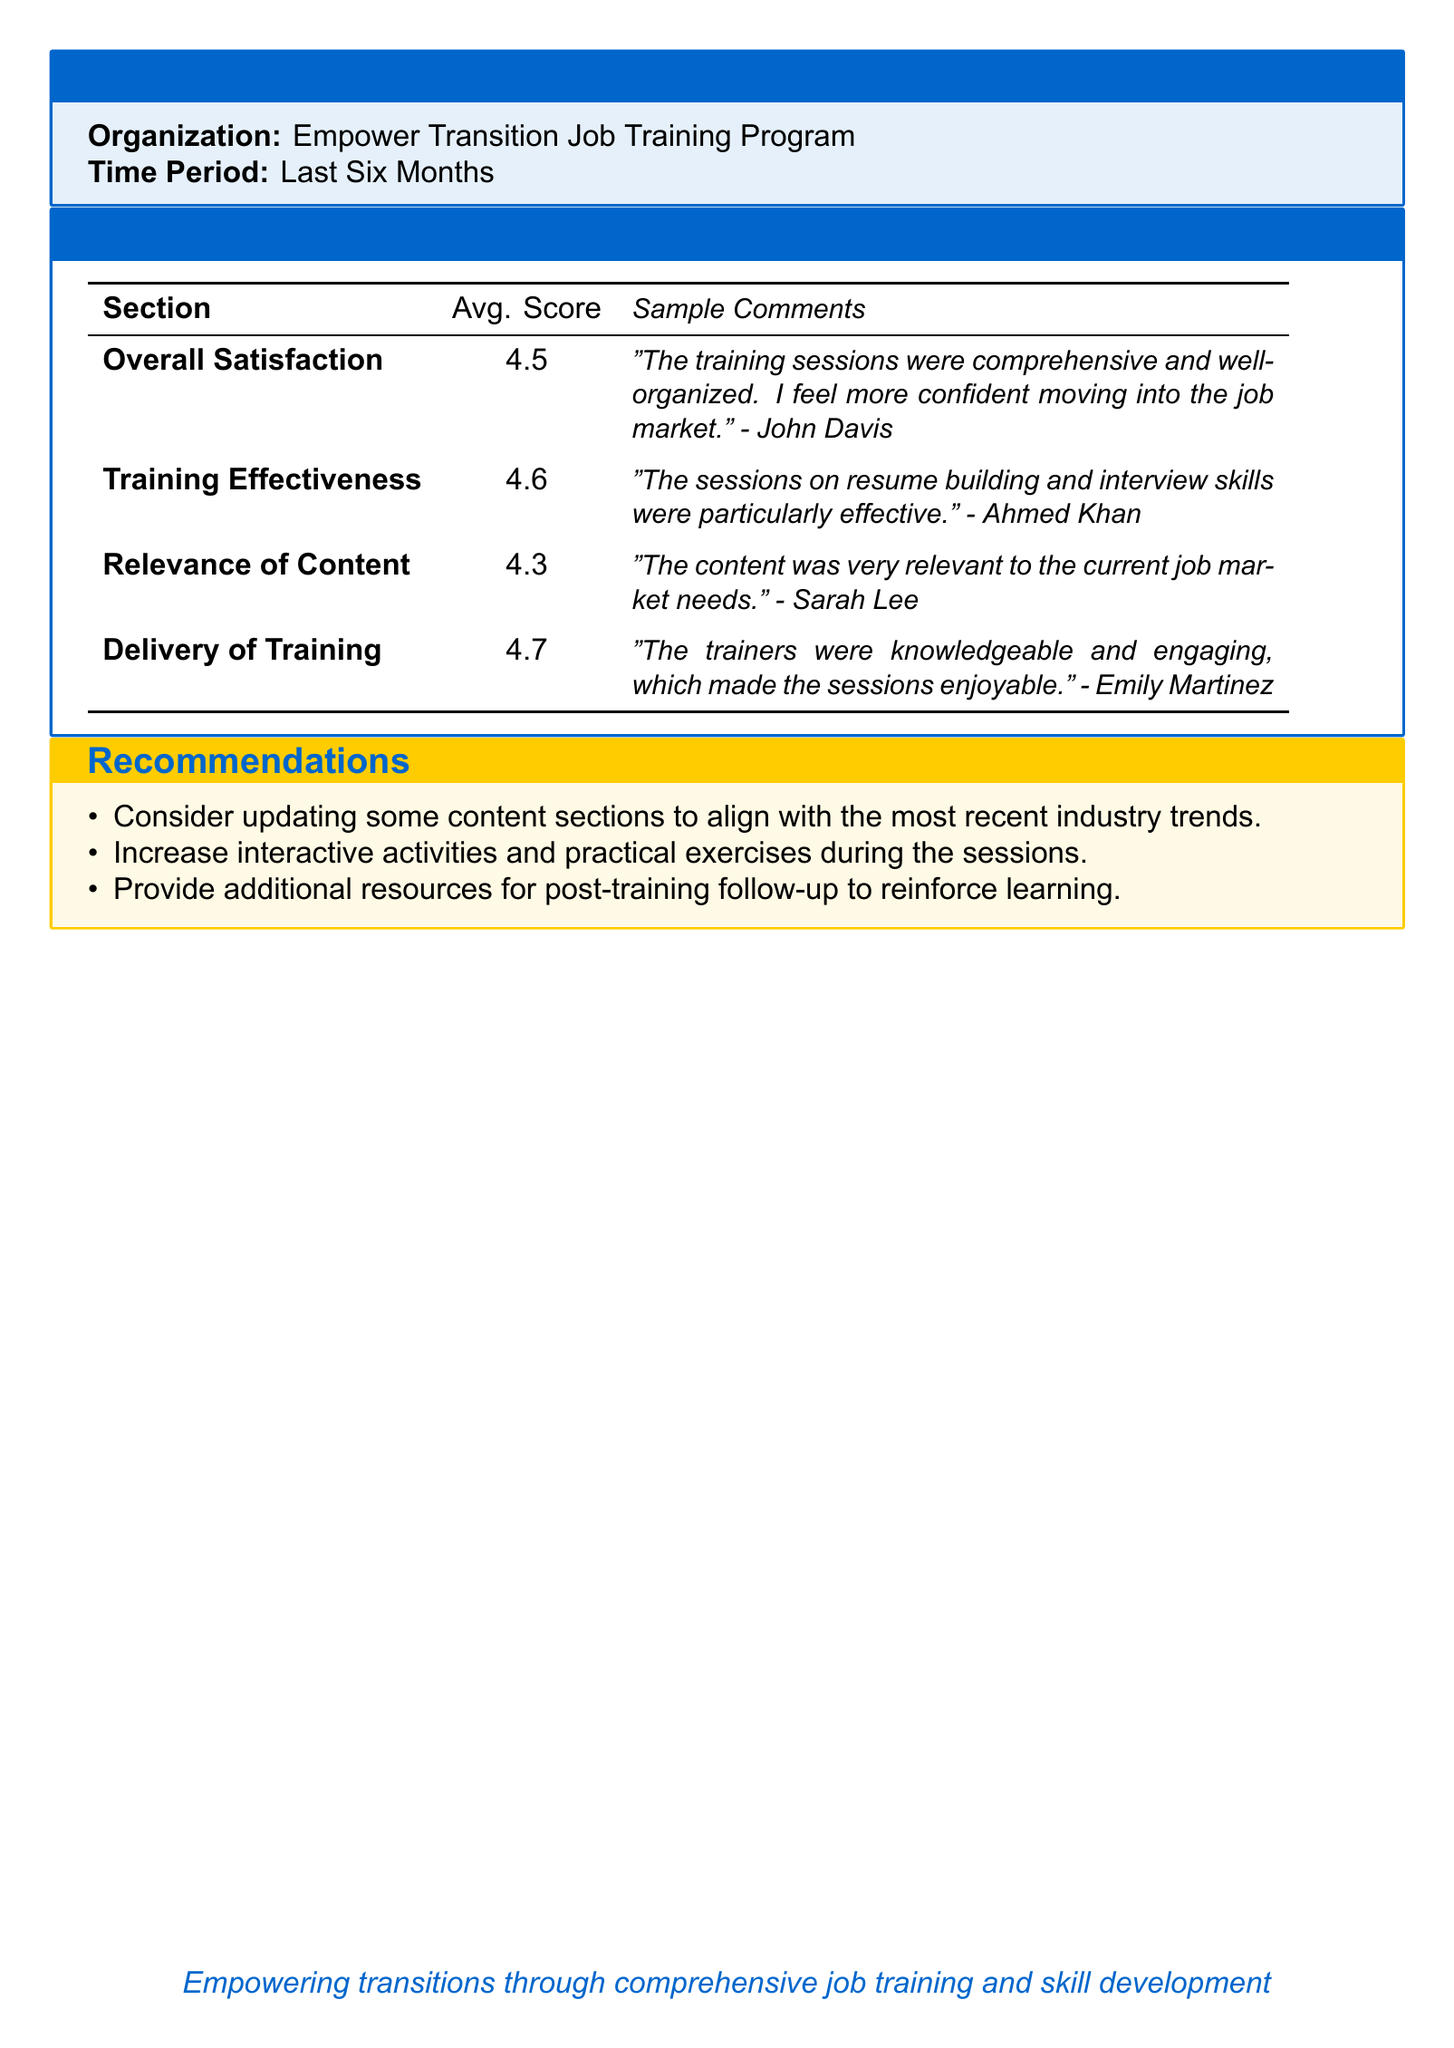What is the average score for Overall Satisfaction? The average score for Overall Satisfaction is listed in the survey results section of the document.
Answer: 4.5 What is the name of the organization conducting the program? The name of the organization is mentioned in the title section of the document.
Answer: Empower Transition Job Training Program What does the comment from John Davis say? The comment from John Davis is included in the sample comments under Overall Satisfaction in the survey results.
Answer: "The training sessions were comprehensive and well-organized. I feel more confident moving into the job market." What was the average score for Training Effectiveness? The document specifies the average score for Training Effectiveness in the survey results table.
Answer: 4.6 What recommendations are made regarding interactive activities? Recommendations for interactive activities are presented in the recommendations section of the document.
Answer: Increase interactive activities and practical exercises during the sessions What was the lowest average score reported in the survey? The lowest average score is derived from the survey results table provided in the document.
Answer: 4.3 Who made the comment about resume building and interview skills? The comment regarding resume building and interview skills is attributed to a participant mentioned in the survey results.
Answer: Ahmed Khan How many months does the survey's time period cover? The time period for the survey results is explicitly stated at the beginning of the document.
Answer: Last Six Months 